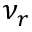Convert formula to latex. <formula><loc_0><loc_0><loc_500><loc_500>\nu _ { r }</formula> 